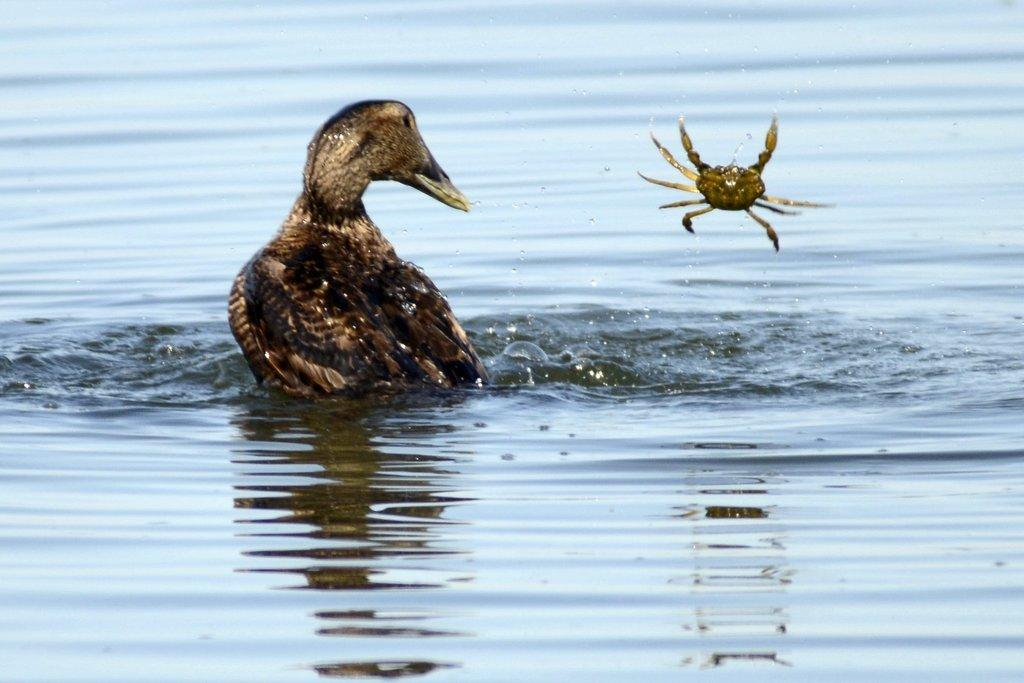What is the main subject in the center of the image? There is a bird in the center of the image. What body of water is visible at the bottom of the image? There is a river at the bottom of the image. Is there any other animal or creature present in the image besides the bird? There is a mention of a crab in the air, although this may be a transcription error as crabs are not typically found in the air. What type of design is featured on the vegetable in the image? There is no vegetable present in the image, so it is not possible to answer that question. 